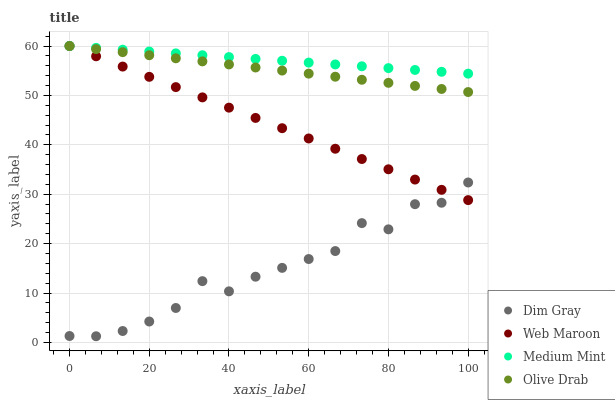Does Dim Gray have the minimum area under the curve?
Answer yes or no. Yes. Does Medium Mint have the maximum area under the curve?
Answer yes or no. Yes. Does Web Maroon have the minimum area under the curve?
Answer yes or no. No. Does Web Maroon have the maximum area under the curve?
Answer yes or no. No. Is Medium Mint the smoothest?
Answer yes or no. Yes. Is Dim Gray the roughest?
Answer yes or no. Yes. Is Web Maroon the smoothest?
Answer yes or no. No. Is Web Maroon the roughest?
Answer yes or no. No. Does Dim Gray have the lowest value?
Answer yes or no. Yes. Does Web Maroon have the lowest value?
Answer yes or no. No. Does Olive Drab have the highest value?
Answer yes or no. Yes. Does Dim Gray have the highest value?
Answer yes or no. No. Is Dim Gray less than Medium Mint?
Answer yes or no. Yes. Is Olive Drab greater than Dim Gray?
Answer yes or no. Yes. Does Medium Mint intersect Olive Drab?
Answer yes or no. Yes. Is Medium Mint less than Olive Drab?
Answer yes or no. No. Is Medium Mint greater than Olive Drab?
Answer yes or no. No. Does Dim Gray intersect Medium Mint?
Answer yes or no. No. 